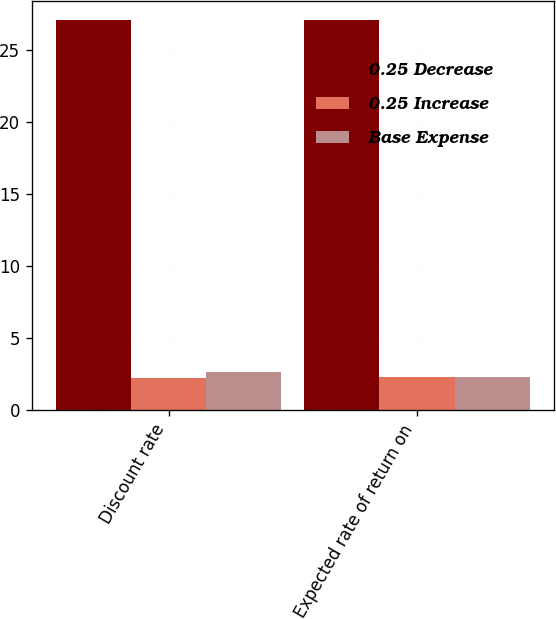Convert chart. <chart><loc_0><loc_0><loc_500><loc_500><stacked_bar_chart><ecel><fcel>Discount rate<fcel>Expected rate of return on<nl><fcel>0.25 Decrease<fcel>27.1<fcel>27.1<nl><fcel>0.25 Increase<fcel>2.2<fcel>2.3<nl><fcel>Base Expense<fcel>2.6<fcel>2.3<nl></chart> 